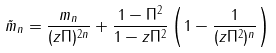<formula> <loc_0><loc_0><loc_500><loc_500>\tilde { m } _ { n } = \frac { m _ { n } } { ( z \Pi ) ^ { 2 n } } + \frac { 1 - \Pi ^ { 2 } } { 1 - z \Pi ^ { 2 } } \left ( 1 - \frac { 1 } { ( z \Pi ^ { 2 } ) ^ { n } } \right )</formula> 